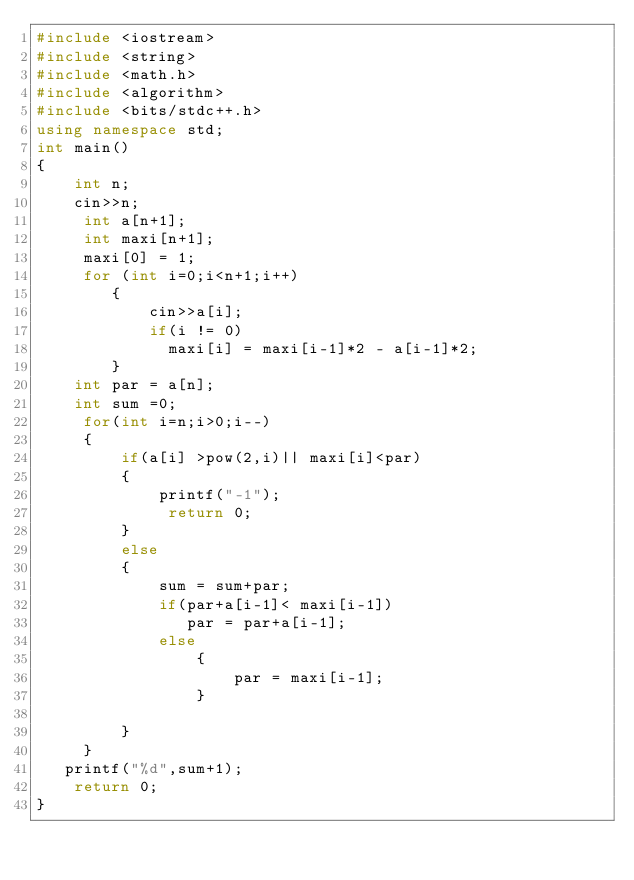Convert code to text. <code><loc_0><loc_0><loc_500><loc_500><_C++_>#include <iostream>
#include <string>
#include <math.h>
#include <algorithm>
#include <bits/stdc++.h>
using namespace std;
int main()
{
    int n;
    cin>>n;
     int a[n+1];
     int maxi[n+1];
     maxi[0] = 1;
     for (int i=0;i<n+1;i++)
        {
            cin>>a[i];
            if(i != 0)
              maxi[i] = maxi[i-1]*2 - a[i-1]*2;
        }
    int par = a[n];
    int sum =0;
     for(int i=n;i>0;i--)
     {
         if(a[i] >pow(2,i)|| maxi[i]<par)
         {
             printf("-1");
              return 0;
         }
         else
         {
             sum = sum+par;
             if(par+a[i-1]< maxi[i-1])
                par = par+a[i-1];
             else
                 {
                     par = maxi[i-1];
                 }

         }
     }
   printf("%d",sum+1);
    return 0;
}
</code> 